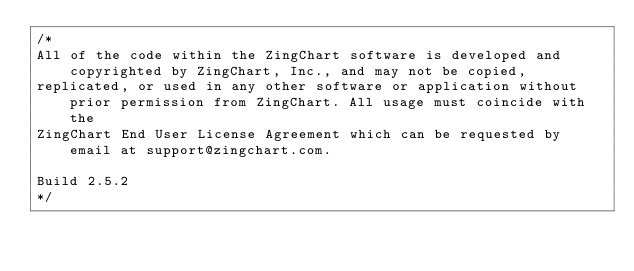<code> <loc_0><loc_0><loc_500><loc_500><_JavaScript_>/*
All of the code within the ZingChart software is developed and copyrighted by ZingChart, Inc., and may not be copied,
replicated, or used in any other software or application without prior permission from ZingChart. All usage must coincide with the
ZingChart End User License Agreement which can be requested by email at support@zingchart.com.

Build 2.5.2
*/</code> 